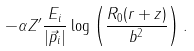<formula> <loc_0><loc_0><loc_500><loc_500>- \alpha Z ^ { \prime } \frac { E _ { i } } { | \vec { p } _ { i } | } \log \left ( \frac { R _ { 0 } ( r + z ) } { b ^ { 2 } } \right ) .</formula> 